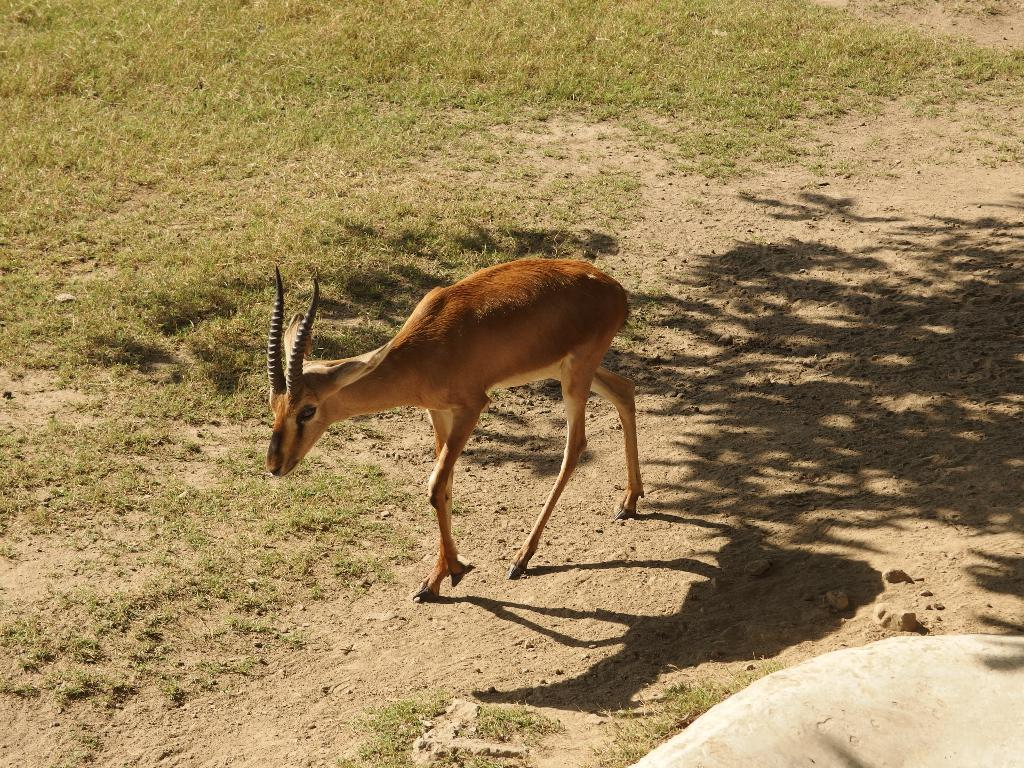What animal can be seen in the image? There is a deer in the image. Where is the deer located? The deer is on the land. What type of vegetation is visible in the image? There is grass visible at the top of the image. What object can be seen in the right bottom of the image? There is a rock in the right bottom of the image. What type of car can be seen in the image? There is no car present in the image; it features a deer on the land. What observation can be made about the temperature in the image? The image does not provide any information about the temperature, so it cannot be determined from the image. 